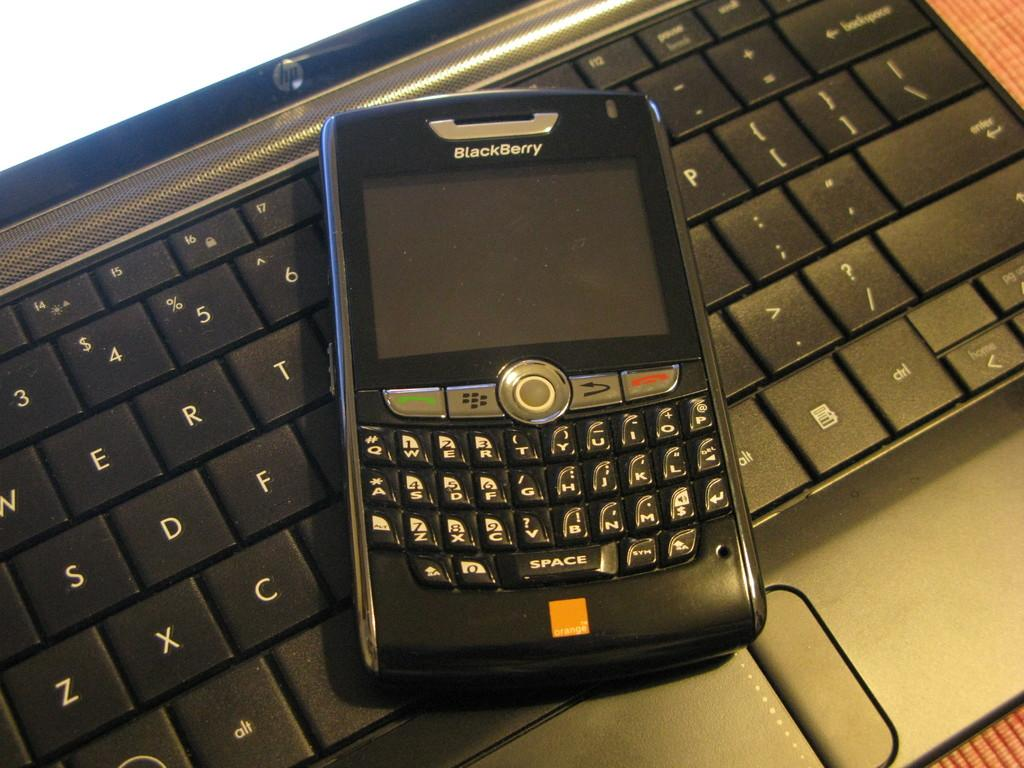<image>
Present a compact description of the photo's key features. A blackberry phone sits on top of a laptop keyboard 